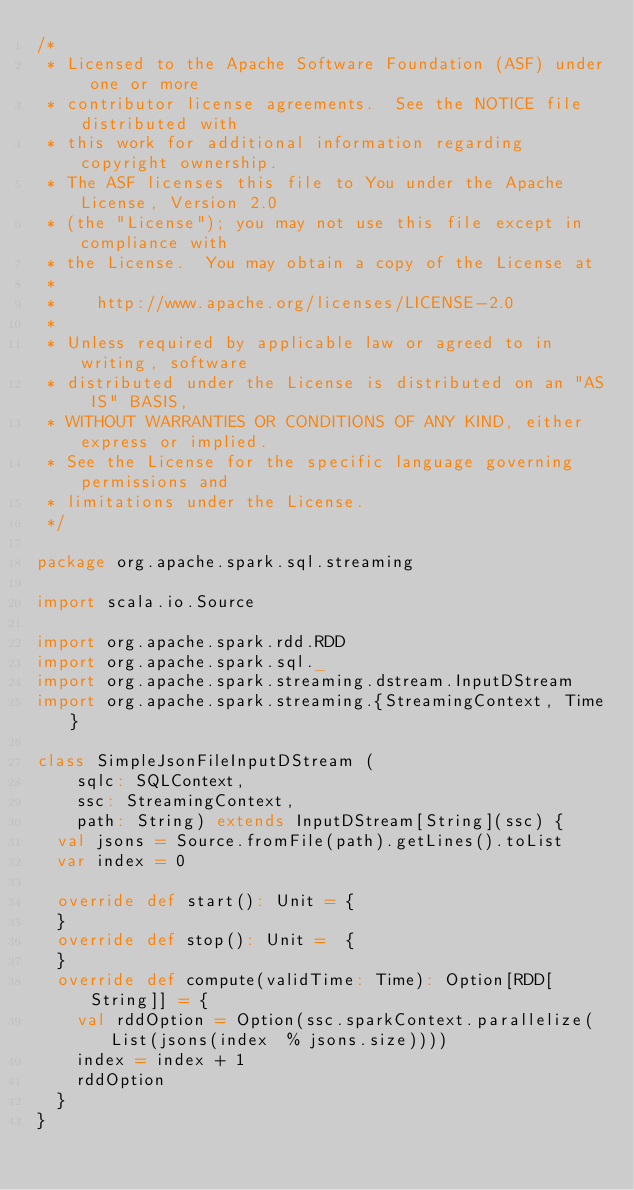Convert code to text. <code><loc_0><loc_0><loc_500><loc_500><_Scala_>/*
 * Licensed to the Apache Software Foundation (ASF) under one or more
 * contributor license agreements.  See the NOTICE file distributed with
 * this work for additional information regarding copyright ownership.
 * The ASF licenses this file to You under the Apache License, Version 2.0
 * (the "License"); you may not use this file except in compliance with
 * the License.  You may obtain a copy of the License at
 *
 *    http://www.apache.org/licenses/LICENSE-2.0
 *
 * Unless required by applicable law or agreed to in writing, software
 * distributed under the License is distributed on an "AS IS" BASIS,
 * WITHOUT WARRANTIES OR CONDITIONS OF ANY KIND, either express or implied.
 * See the License for the specific language governing permissions and
 * limitations under the License.
 */

package org.apache.spark.sql.streaming

import scala.io.Source

import org.apache.spark.rdd.RDD
import org.apache.spark.sql._
import org.apache.spark.streaming.dstream.InputDStream
import org.apache.spark.streaming.{StreamingContext, Time}

class SimpleJsonFileInputDStream (
    sqlc: SQLContext,
    ssc: StreamingContext,
    path: String) extends InputDStream[String](ssc) {
  val jsons = Source.fromFile(path).getLines().toList
  var index = 0

  override def start(): Unit = {
  }
  override def stop(): Unit =  {
  }
  override def compute(validTime: Time): Option[RDD[String]] = {
    val rddOption = Option(ssc.sparkContext.parallelize(List(jsons(index  % jsons.size))))
    index = index + 1
    rddOption
  }
}
</code> 